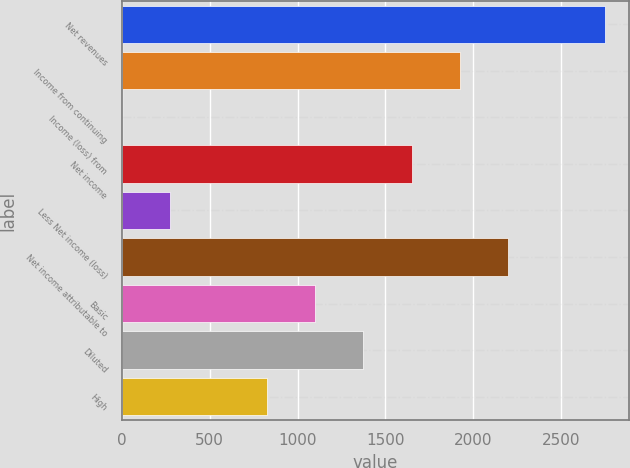Convert chart to OTSL. <chart><loc_0><loc_0><loc_500><loc_500><bar_chart><fcel>Net revenues<fcel>Income from continuing<fcel>Income (loss) from<fcel>Net income<fcel>Less Net income (loss)<fcel>Net income attributable to<fcel>Basic<fcel>Diluted<fcel>High<nl><fcel>2749<fcel>1924.6<fcel>1<fcel>1649.8<fcel>275.8<fcel>2199.4<fcel>1100.2<fcel>1375<fcel>825.4<nl></chart> 